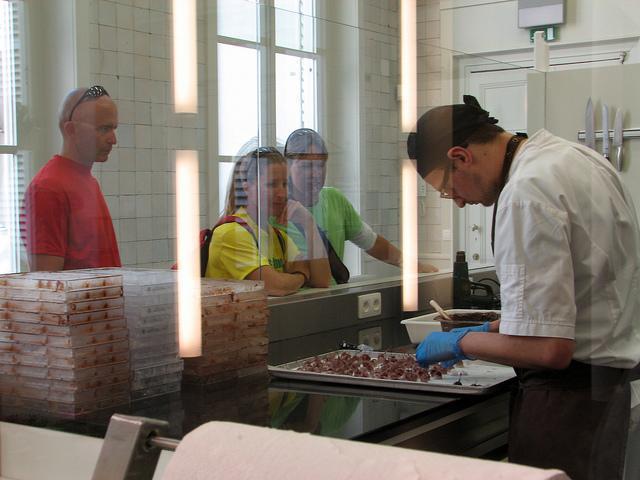What is the man using to cook?
Pick the correct solution from the four options below to address the question.
Options: Veggies, chocolate, meat, fruit. Chocolate. 